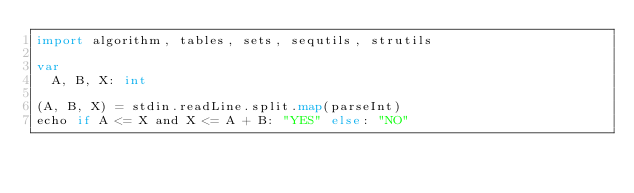Convert code to text. <code><loc_0><loc_0><loc_500><loc_500><_Nim_>import algorithm, tables, sets, sequtils, strutils

var
  A, B, X: int

(A, B, X) = stdin.readLine.split.map(parseInt)
echo if A <= X and X <= A + B: "YES" else: "NO"</code> 